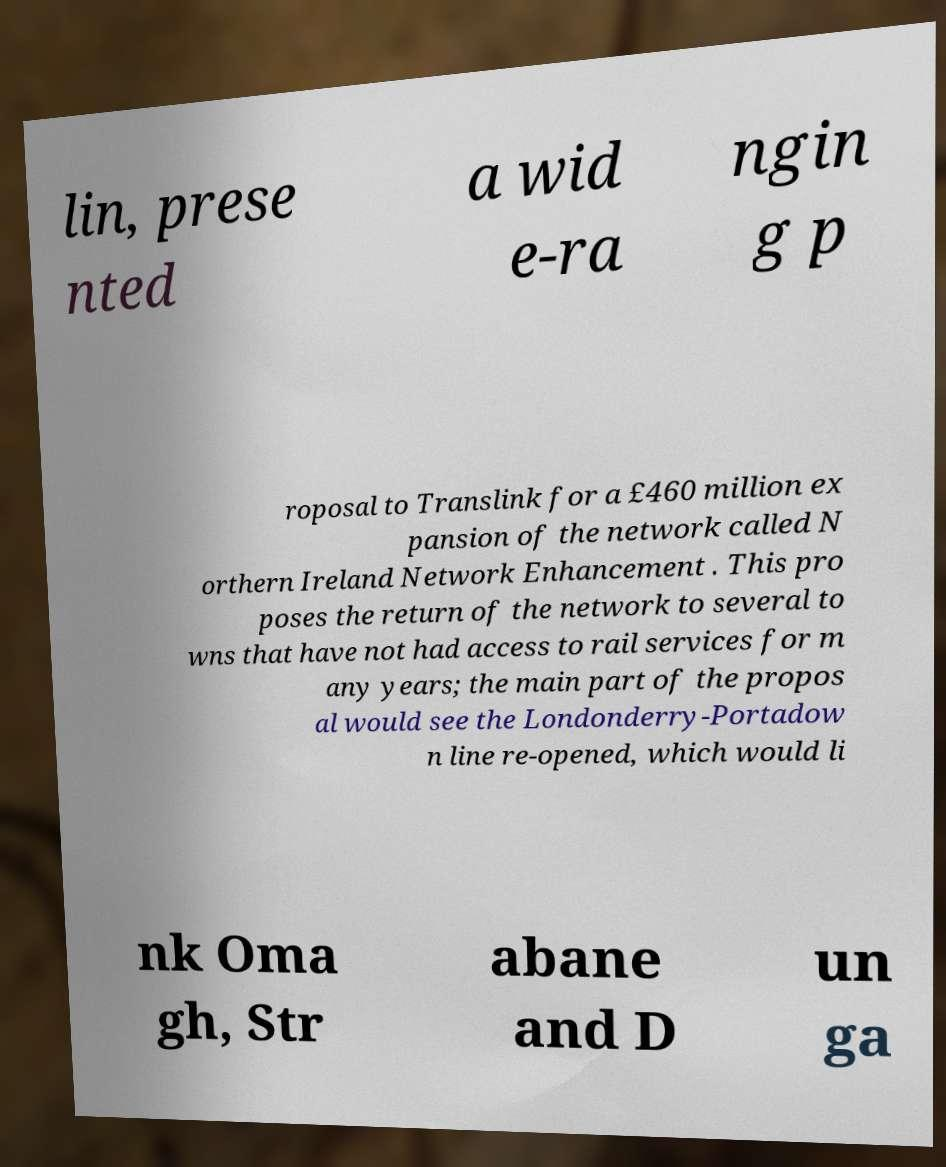There's text embedded in this image that I need extracted. Can you transcribe it verbatim? lin, prese nted a wid e-ra ngin g p roposal to Translink for a £460 million ex pansion of the network called N orthern Ireland Network Enhancement . This pro poses the return of the network to several to wns that have not had access to rail services for m any years; the main part of the propos al would see the Londonderry-Portadow n line re-opened, which would li nk Oma gh, Str abane and D un ga 